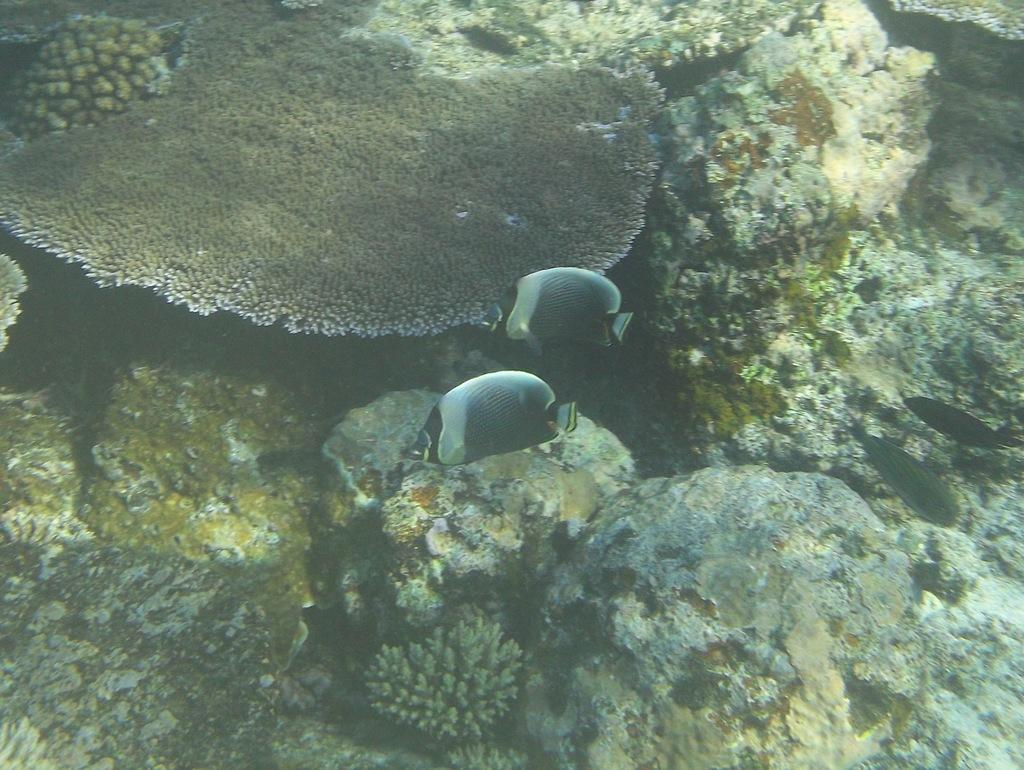What is located in the center of the image? There are fishes in the water in the center of the image. What can be seen in the background of the image? There is algae visible in the background of the image. What type of machine can be seen operating in the image? There is no machine present in the image; it features fishes in the water and algae in the background. 